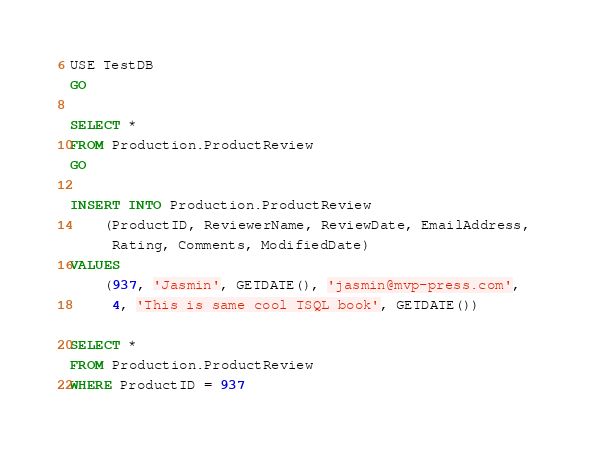Convert code to text. <code><loc_0><loc_0><loc_500><loc_500><_SQL_>USE TestDB
GO

SELECT *
FROM Production.ProductReview
GO

INSERT INTO Production.ProductReview
	(ProductID, ReviewerName, ReviewDate, EmailAddress, 
	 Rating, Comments, ModifiedDate)
VALUES
	(937, 'Jasmin', GETDATE(), 'jasmin@mvp-press.com', 
	 4, 'This is same cool TSQL book', GETDATE())

SELECT *
FROM Production.ProductReview
WHERE ProductID = 937</code> 